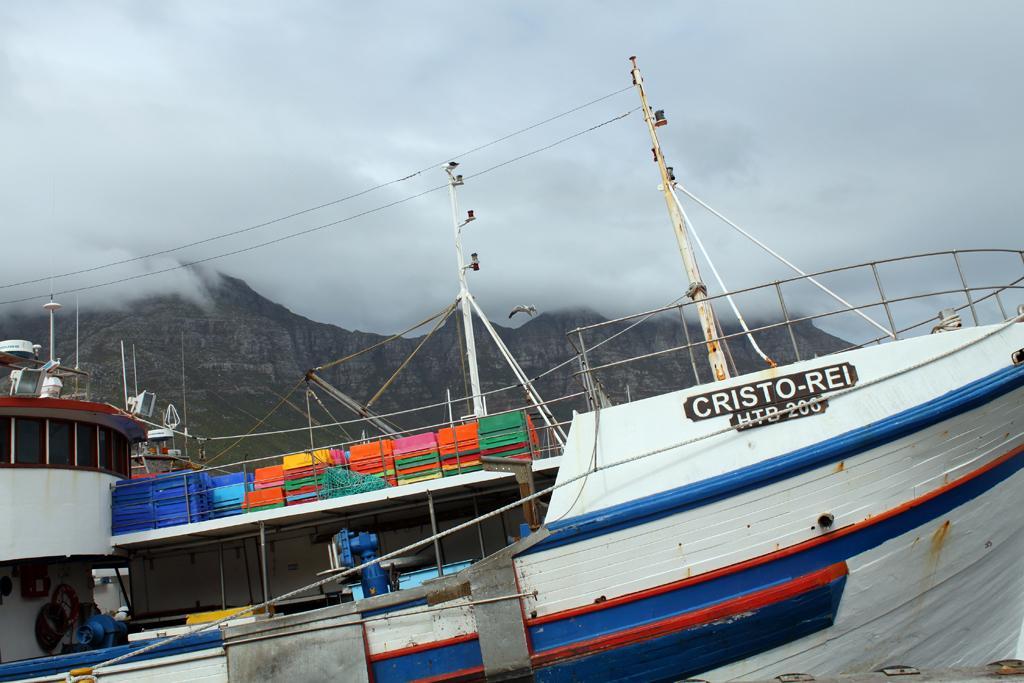Please provide a concise description of this image. Here we can see a ship,poles,ropes,fence and some other objects on it. In the background there is a mountain,smoke and sky. 